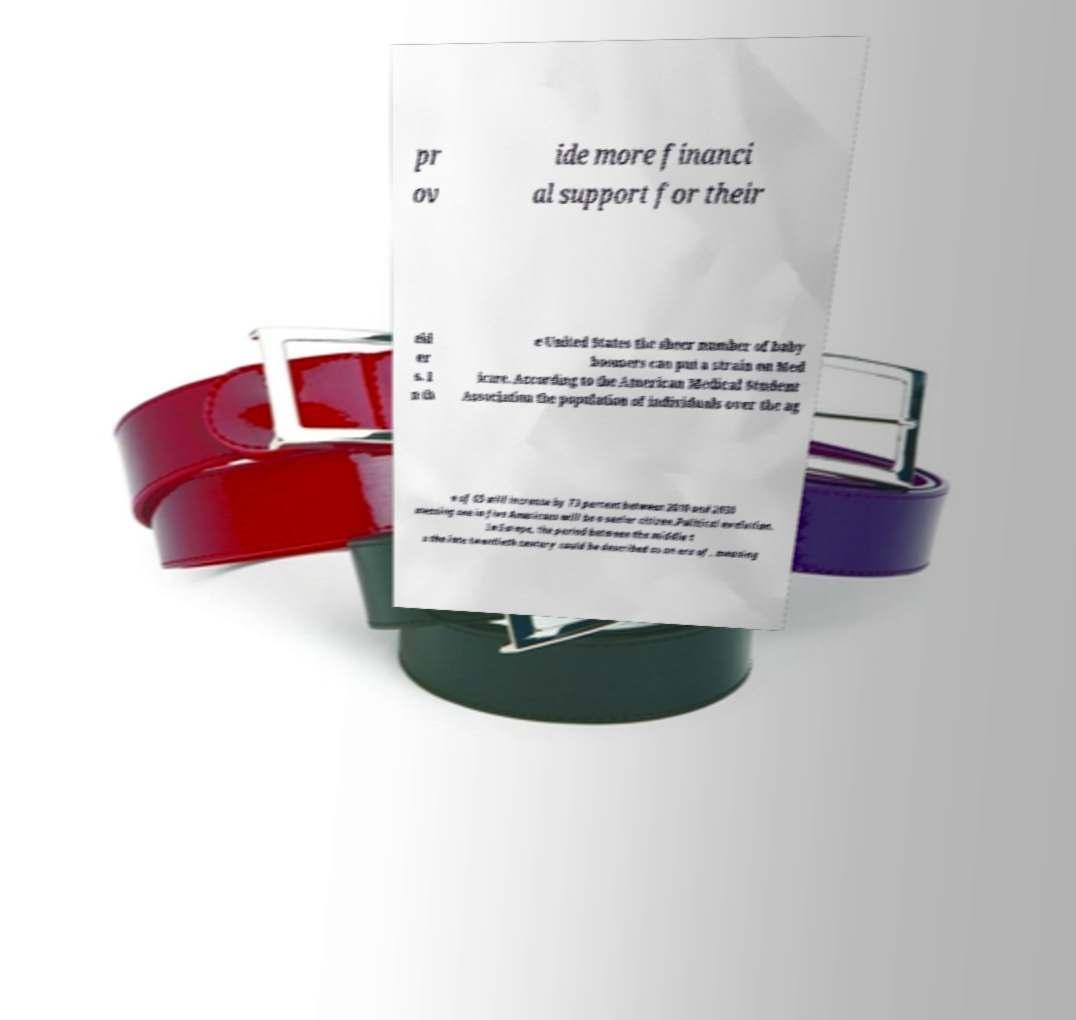Can you read and provide the text displayed in the image?This photo seems to have some interesting text. Can you extract and type it out for me? pr ov ide more financi al support for their eld er s. I n th e United States the sheer number of baby boomers can put a strain on Med icare. According to the American Medical Student Association the population of individuals over the ag e of 65 will increase by 73 percent between 2010 and 2030 meaning one in five Americans will be a senior citizen.Political evolution. In Europe, the period between the middle t o the late twentieth century could be described as an era of , meaning 